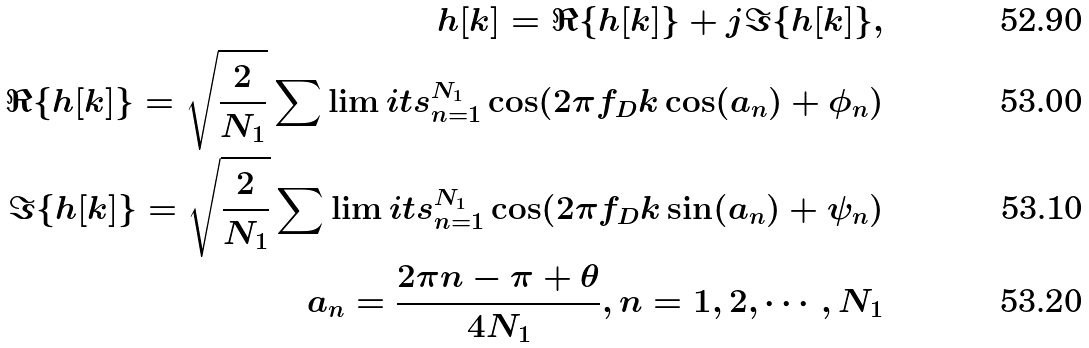<formula> <loc_0><loc_0><loc_500><loc_500>h [ k ] = \Re \{ h [ k ] \} + j \Im \{ h [ k ] \} , \\ \Re \{ h [ k ] \} = \sqrt { \frac { 2 } { N _ { 1 } } } \sum \lim i t s _ { n = 1 } ^ { N _ { 1 } } \cos ( 2 \pi f _ { D } k \cos ( a _ { n } ) + \phi _ { n } ) \\ \Im \{ h [ k ] \} = \sqrt { \frac { 2 } { N _ { 1 } } } \sum \lim i t s _ { n = 1 } ^ { N _ { 1 } } \cos ( 2 \pi f _ { D } k \sin ( a _ { n } ) + \psi _ { n } ) \\ a _ { n } = \frac { 2 \pi n - \pi + \theta } { 4 N _ { 1 } } , n = 1 , 2 , \cdots , N _ { 1 }</formula> 